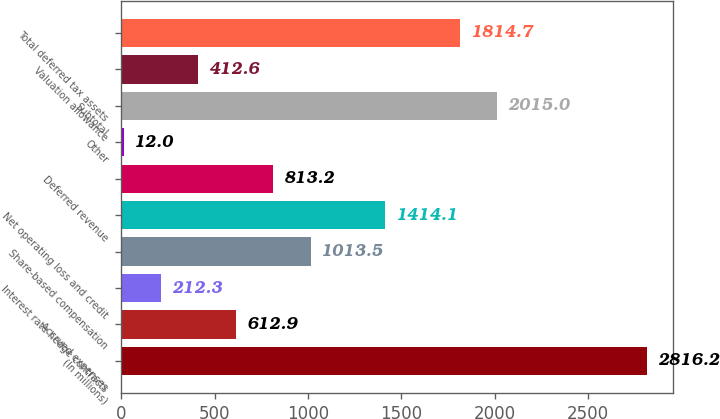<chart> <loc_0><loc_0><loc_500><loc_500><bar_chart><fcel>(In millions)<fcel>Accrued expenses<fcel>Interest rate hedge contracts<fcel>Share-based compensation<fcel>Net operating loss and credit<fcel>Deferred revenue<fcel>Other<fcel>Subtotal<fcel>Valuation allowance<fcel>Total deferred tax assets<nl><fcel>2816.2<fcel>612.9<fcel>212.3<fcel>1013.5<fcel>1414.1<fcel>813.2<fcel>12<fcel>2015<fcel>412.6<fcel>1814.7<nl></chart> 